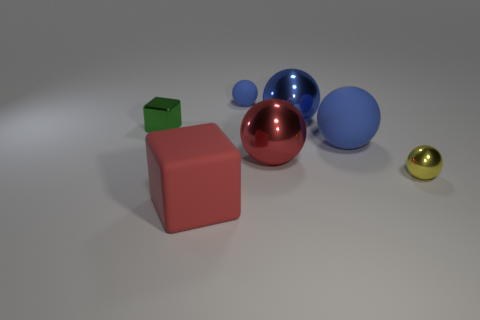How many blue spheres must be subtracted to get 1 blue spheres? 2 Subtract all big red balls. How many balls are left? 4 Subtract all cyan cubes. How many blue balls are left? 3 Add 2 yellow shiny objects. How many objects exist? 9 Subtract 4 balls. How many balls are left? 1 Subtract all blue spheres. How many spheres are left? 2 Subtract all spheres. How many objects are left? 2 Subtract all purple spheres. Subtract all blue cubes. How many spheres are left? 5 Subtract all tiny blue blocks. Subtract all tiny matte objects. How many objects are left? 6 Add 1 tiny metallic balls. How many tiny metallic balls are left? 2 